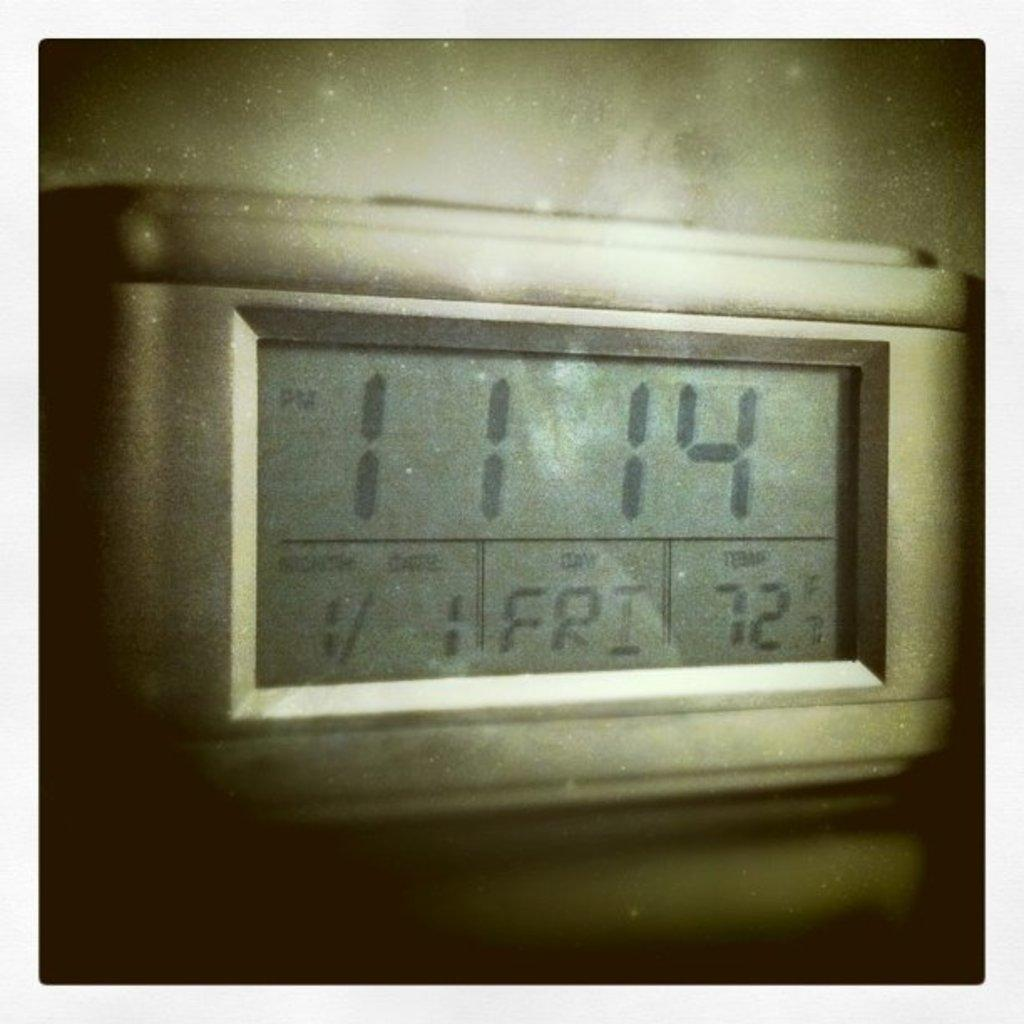<image>
Share a concise interpretation of the image provided. A thermostat display that reads 11:14 pm, on 1/1 Friday 72 degrees F. 